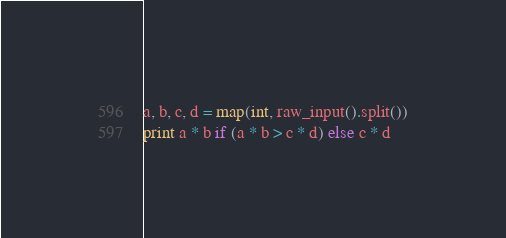Convert code to text. <code><loc_0><loc_0><loc_500><loc_500><_Python_>a, b, c, d = map(int, raw_input().split())
print a * b if (a * b > c * d) else c * d</code> 